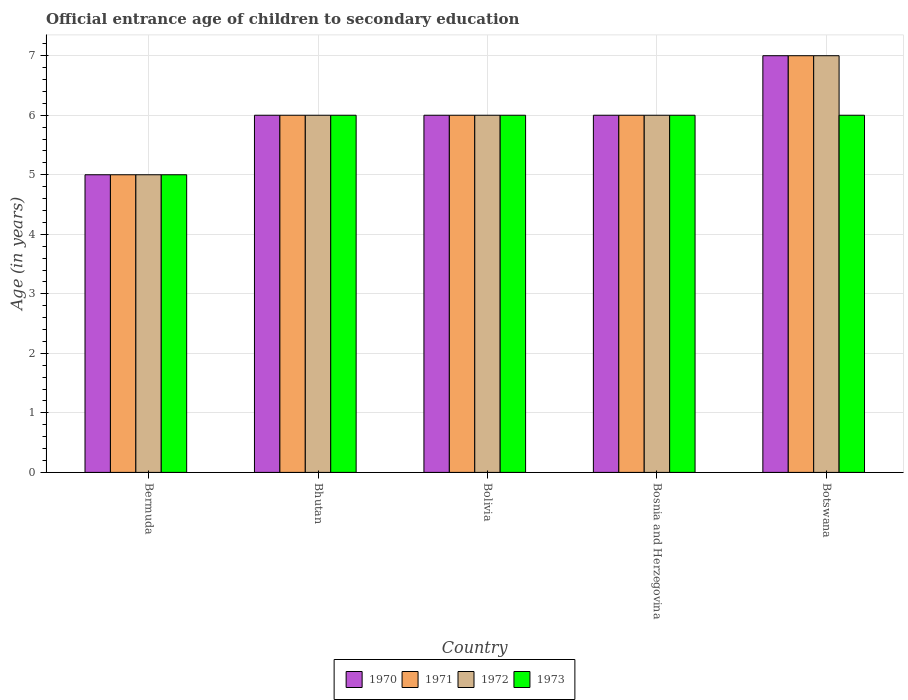How many different coloured bars are there?
Your answer should be very brief. 4. How many groups of bars are there?
Give a very brief answer. 5. Are the number of bars per tick equal to the number of legend labels?
Your answer should be very brief. Yes. How many bars are there on the 2nd tick from the left?
Your response must be concise. 4. How many bars are there on the 5th tick from the right?
Give a very brief answer. 4. What is the label of the 1st group of bars from the left?
Give a very brief answer. Bermuda. In how many cases, is the number of bars for a given country not equal to the number of legend labels?
Ensure brevity in your answer.  0. In which country was the secondary school starting age of children in 1973 maximum?
Your answer should be very brief. Bhutan. In which country was the secondary school starting age of children in 1971 minimum?
Provide a short and direct response. Bermuda. What is the difference between the secondary school starting age of children in 1970 in Bermuda and that in Bosnia and Herzegovina?
Provide a short and direct response. -1. What is the difference between the secondary school starting age of children in 1971 in Botswana and the secondary school starting age of children in 1970 in Bermuda?
Make the answer very short. 2. What is the difference between the secondary school starting age of children of/in 1971 and secondary school starting age of children of/in 1973 in Bermuda?
Provide a succinct answer. 0. What is the difference between the highest and the second highest secondary school starting age of children in 1970?
Ensure brevity in your answer.  -1. Is it the case that in every country, the sum of the secondary school starting age of children in 1973 and secondary school starting age of children in 1970 is greater than the sum of secondary school starting age of children in 1972 and secondary school starting age of children in 1971?
Offer a terse response. No. What does the 4th bar from the right in Bosnia and Herzegovina represents?
Provide a short and direct response. 1970. Is it the case that in every country, the sum of the secondary school starting age of children in 1971 and secondary school starting age of children in 1970 is greater than the secondary school starting age of children in 1973?
Make the answer very short. Yes. Are the values on the major ticks of Y-axis written in scientific E-notation?
Provide a succinct answer. No. How are the legend labels stacked?
Your response must be concise. Horizontal. What is the title of the graph?
Your answer should be very brief. Official entrance age of children to secondary education. Does "1993" appear as one of the legend labels in the graph?
Provide a short and direct response. No. What is the label or title of the Y-axis?
Make the answer very short. Age (in years). What is the Age (in years) of 1970 in Bermuda?
Provide a succinct answer. 5. What is the Age (in years) in 1972 in Bermuda?
Make the answer very short. 5. What is the Age (in years) of 1973 in Bermuda?
Keep it short and to the point. 5. What is the Age (in years) in 1970 in Bhutan?
Keep it short and to the point. 6. What is the Age (in years) in 1971 in Bhutan?
Keep it short and to the point. 6. What is the Age (in years) in 1972 in Bhutan?
Your response must be concise. 6. What is the Age (in years) of 1973 in Bhutan?
Offer a very short reply. 6. What is the Age (in years) of 1971 in Bolivia?
Offer a very short reply. 6. What is the Age (in years) of 1970 in Bosnia and Herzegovina?
Provide a succinct answer. 6. What is the Age (in years) in 1971 in Bosnia and Herzegovina?
Offer a very short reply. 6. What is the Age (in years) of 1970 in Botswana?
Ensure brevity in your answer.  7. What is the Age (in years) of 1971 in Botswana?
Offer a very short reply. 7. What is the Age (in years) in 1972 in Botswana?
Your answer should be compact. 7. What is the Age (in years) in 1973 in Botswana?
Your answer should be compact. 6. Across all countries, what is the maximum Age (in years) in 1970?
Make the answer very short. 7. Across all countries, what is the maximum Age (in years) in 1971?
Ensure brevity in your answer.  7. Across all countries, what is the maximum Age (in years) of 1973?
Make the answer very short. 6. Across all countries, what is the minimum Age (in years) in 1971?
Make the answer very short. 5. Across all countries, what is the minimum Age (in years) in 1972?
Give a very brief answer. 5. Across all countries, what is the minimum Age (in years) in 1973?
Keep it short and to the point. 5. What is the total Age (in years) of 1971 in the graph?
Keep it short and to the point. 30. What is the total Age (in years) of 1972 in the graph?
Your answer should be very brief. 30. What is the difference between the Age (in years) of 1970 in Bermuda and that in Bhutan?
Make the answer very short. -1. What is the difference between the Age (in years) of 1972 in Bermuda and that in Bhutan?
Provide a succinct answer. -1. What is the difference between the Age (in years) in 1970 in Bermuda and that in Bolivia?
Your answer should be very brief. -1. What is the difference between the Age (in years) of 1971 in Bermuda and that in Bolivia?
Keep it short and to the point. -1. What is the difference between the Age (in years) in 1970 in Bermuda and that in Bosnia and Herzegovina?
Make the answer very short. -1. What is the difference between the Age (in years) of 1972 in Bermuda and that in Bosnia and Herzegovina?
Your answer should be very brief. -1. What is the difference between the Age (in years) in 1970 in Bermuda and that in Botswana?
Ensure brevity in your answer.  -2. What is the difference between the Age (in years) in 1973 in Bermuda and that in Botswana?
Give a very brief answer. -1. What is the difference between the Age (in years) of 1970 in Bhutan and that in Bolivia?
Provide a succinct answer. 0. What is the difference between the Age (in years) of 1972 in Bhutan and that in Bolivia?
Offer a terse response. 0. What is the difference between the Age (in years) of 1973 in Bhutan and that in Bolivia?
Your response must be concise. 0. What is the difference between the Age (in years) of 1970 in Bhutan and that in Bosnia and Herzegovina?
Provide a short and direct response. 0. What is the difference between the Age (in years) of 1971 in Bhutan and that in Bosnia and Herzegovina?
Ensure brevity in your answer.  0. What is the difference between the Age (in years) in 1972 in Bhutan and that in Bosnia and Herzegovina?
Make the answer very short. 0. What is the difference between the Age (in years) in 1973 in Bhutan and that in Bosnia and Herzegovina?
Ensure brevity in your answer.  0. What is the difference between the Age (in years) in 1970 in Bhutan and that in Botswana?
Provide a short and direct response. -1. What is the difference between the Age (in years) of 1971 in Bhutan and that in Botswana?
Offer a very short reply. -1. What is the difference between the Age (in years) of 1972 in Bhutan and that in Botswana?
Keep it short and to the point. -1. What is the difference between the Age (in years) of 1970 in Bolivia and that in Bosnia and Herzegovina?
Your response must be concise. 0. What is the difference between the Age (in years) in 1971 in Bolivia and that in Bosnia and Herzegovina?
Offer a terse response. 0. What is the difference between the Age (in years) of 1972 in Bolivia and that in Bosnia and Herzegovina?
Ensure brevity in your answer.  0. What is the difference between the Age (in years) in 1971 in Bolivia and that in Botswana?
Ensure brevity in your answer.  -1. What is the difference between the Age (in years) in 1972 in Bolivia and that in Botswana?
Your response must be concise. -1. What is the difference between the Age (in years) of 1970 in Bosnia and Herzegovina and that in Botswana?
Ensure brevity in your answer.  -1. What is the difference between the Age (in years) of 1971 in Bosnia and Herzegovina and that in Botswana?
Ensure brevity in your answer.  -1. What is the difference between the Age (in years) of 1972 in Bosnia and Herzegovina and that in Botswana?
Give a very brief answer. -1. What is the difference between the Age (in years) in 1973 in Bosnia and Herzegovina and that in Botswana?
Your response must be concise. 0. What is the difference between the Age (in years) in 1970 in Bermuda and the Age (in years) in 1971 in Bhutan?
Offer a terse response. -1. What is the difference between the Age (in years) in 1970 in Bermuda and the Age (in years) in 1972 in Bhutan?
Offer a very short reply. -1. What is the difference between the Age (in years) in 1970 in Bermuda and the Age (in years) in 1973 in Bhutan?
Your answer should be compact. -1. What is the difference between the Age (in years) in 1971 in Bermuda and the Age (in years) in 1972 in Bhutan?
Make the answer very short. -1. What is the difference between the Age (in years) in 1971 in Bermuda and the Age (in years) in 1973 in Bhutan?
Make the answer very short. -1. What is the difference between the Age (in years) of 1972 in Bermuda and the Age (in years) of 1973 in Bhutan?
Your response must be concise. -1. What is the difference between the Age (in years) of 1970 in Bermuda and the Age (in years) of 1973 in Bolivia?
Your response must be concise. -1. What is the difference between the Age (in years) of 1972 in Bermuda and the Age (in years) of 1973 in Bolivia?
Make the answer very short. -1. What is the difference between the Age (in years) of 1970 in Bermuda and the Age (in years) of 1972 in Bosnia and Herzegovina?
Your answer should be very brief. -1. What is the difference between the Age (in years) of 1972 in Bermuda and the Age (in years) of 1973 in Bosnia and Herzegovina?
Give a very brief answer. -1. What is the difference between the Age (in years) of 1970 in Bermuda and the Age (in years) of 1971 in Botswana?
Offer a very short reply. -2. What is the difference between the Age (in years) in 1971 in Bermuda and the Age (in years) in 1972 in Botswana?
Keep it short and to the point. -2. What is the difference between the Age (in years) of 1972 in Bermuda and the Age (in years) of 1973 in Botswana?
Provide a succinct answer. -1. What is the difference between the Age (in years) in 1970 in Bhutan and the Age (in years) in 1971 in Bolivia?
Your answer should be compact. 0. What is the difference between the Age (in years) in 1970 in Bhutan and the Age (in years) in 1972 in Bolivia?
Give a very brief answer. 0. What is the difference between the Age (in years) in 1971 in Bhutan and the Age (in years) in 1972 in Bolivia?
Ensure brevity in your answer.  0. What is the difference between the Age (in years) of 1970 in Bhutan and the Age (in years) of 1972 in Bosnia and Herzegovina?
Keep it short and to the point. 0. What is the difference between the Age (in years) in 1970 in Bhutan and the Age (in years) in 1973 in Bosnia and Herzegovina?
Make the answer very short. 0. What is the difference between the Age (in years) in 1972 in Bhutan and the Age (in years) in 1973 in Bosnia and Herzegovina?
Keep it short and to the point. 0. What is the difference between the Age (in years) in 1970 in Bhutan and the Age (in years) in 1971 in Botswana?
Your answer should be very brief. -1. What is the difference between the Age (in years) in 1970 in Bhutan and the Age (in years) in 1973 in Botswana?
Give a very brief answer. 0. What is the difference between the Age (in years) in 1972 in Bhutan and the Age (in years) in 1973 in Botswana?
Your answer should be compact. 0. What is the difference between the Age (in years) of 1970 in Bolivia and the Age (in years) of 1971 in Bosnia and Herzegovina?
Provide a short and direct response. 0. What is the difference between the Age (in years) of 1970 in Bolivia and the Age (in years) of 1973 in Bosnia and Herzegovina?
Your answer should be very brief. 0. What is the difference between the Age (in years) of 1970 in Bolivia and the Age (in years) of 1972 in Botswana?
Your answer should be very brief. -1. What is the difference between the Age (in years) of 1970 in Bosnia and Herzegovina and the Age (in years) of 1971 in Botswana?
Provide a short and direct response. -1. What is the difference between the Age (in years) in 1970 in Bosnia and Herzegovina and the Age (in years) in 1972 in Botswana?
Give a very brief answer. -1. What is the difference between the Age (in years) of 1970 in Bosnia and Herzegovina and the Age (in years) of 1973 in Botswana?
Give a very brief answer. 0. What is the difference between the Age (in years) in 1971 in Bosnia and Herzegovina and the Age (in years) in 1973 in Botswana?
Offer a very short reply. 0. What is the difference between the Age (in years) in 1972 in Bosnia and Herzegovina and the Age (in years) in 1973 in Botswana?
Your answer should be compact. 0. What is the difference between the Age (in years) of 1970 and Age (in years) of 1972 in Bermuda?
Offer a very short reply. 0. What is the difference between the Age (in years) in 1971 and Age (in years) in 1972 in Bermuda?
Give a very brief answer. 0. What is the difference between the Age (in years) in 1970 and Age (in years) in 1972 in Bhutan?
Offer a very short reply. 0. What is the difference between the Age (in years) of 1971 and Age (in years) of 1973 in Bhutan?
Make the answer very short. 0. What is the difference between the Age (in years) in 1972 and Age (in years) in 1973 in Bhutan?
Give a very brief answer. 0. What is the difference between the Age (in years) of 1972 and Age (in years) of 1973 in Bolivia?
Provide a short and direct response. 0. What is the difference between the Age (in years) in 1970 and Age (in years) in 1971 in Bosnia and Herzegovina?
Provide a succinct answer. 0. What is the difference between the Age (in years) of 1971 and Age (in years) of 1973 in Bosnia and Herzegovina?
Provide a short and direct response. 0. What is the difference between the Age (in years) in 1970 and Age (in years) in 1971 in Botswana?
Keep it short and to the point. 0. What is the difference between the Age (in years) in 1970 and Age (in years) in 1973 in Botswana?
Offer a very short reply. 1. What is the difference between the Age (in years) in 1971 and Age (in years) in 1972 in Botswana?
Your answer should be compact. 0. What is the ratio of the Age (in years) of 1970 in Bermuda to that in Bolivia?
Your response must be concise. 0.83. What is the ratio of the Age (in years) in 1972 in Bermuda to that in Bosnia and Herzegovina?
Ensure brevity in your answer.  0.83. What is the ratio of the Age (in years) of 1971 in Bermuda to that in Botswana?
Ensure brevity in your answer.  0.71. What is the ratio of the Age (in years) of 1971 in Bhutan to that in Bolivia?
Provide a short and direct response. 1. What is the ratio of the Age (in years) of 1973 in Bhutan to that in Bolivia?
Your response must be concise. 1. What is the ratio of the Age (in years) in 1970 in Bhutan to that in Bosnia and Herzegovina?
Keep it short and to the point. 1. What is the ratio of the Age (in years) of 1973 in Bhutan to that in Bosnia and Herzegovina?
Offer a very short reply. 1. What is the ratio of the Age (in years) of 1972 in Bolivia to that in Bosnia and Herzegovina?
Ensure brevity in your answer.  1. What is the ratio of the Age (in years) of 1973 in Bolivia to that in Bosnia and Herzegovina?
Ensure brevity in your answer.  1. What is the ratio of the Age (in years) of 1970 in Bolivia to that in Botswana?
Provide a succinct answer. 0.86. What is the ratio of the Age (in years) in 1971 in Bolivia to that in Botswana?
Your answer should be compact. 0.86. What is the ratio of the Age (in years) in 1973 in Bolivia to that in Botswana?
Your response must be concise. 1. What is the ratio of the Age (in years) in 1970 in Bosnia and Herzegovina to that in Botswana?
Your answer should be compact. 0.86. What is the ratio of the Age (in years) of 1971 in Bosnia and Herzegovina to that in Botswana?
Provide a succinct answer. 0.86. What is the ratio of the Age (in years) in 1973 in Bosnia and Herzegovina to that in Botswana?
Make the answer very short. 1. What is the difference between the highest and the second highest Age (in years) in 1970?
Your response must be concise. 1. What is the difference between the highest and the second highest Age (in years) in 1971?
Make the answer very short. 1. What is the difference between the highest and the second highest Age (in years) of 1973?
Make the answer very short. 0. What is the difference between the highest and the lowest Age (in years) of 1972?
Ensure brevity in your answer.  2. 